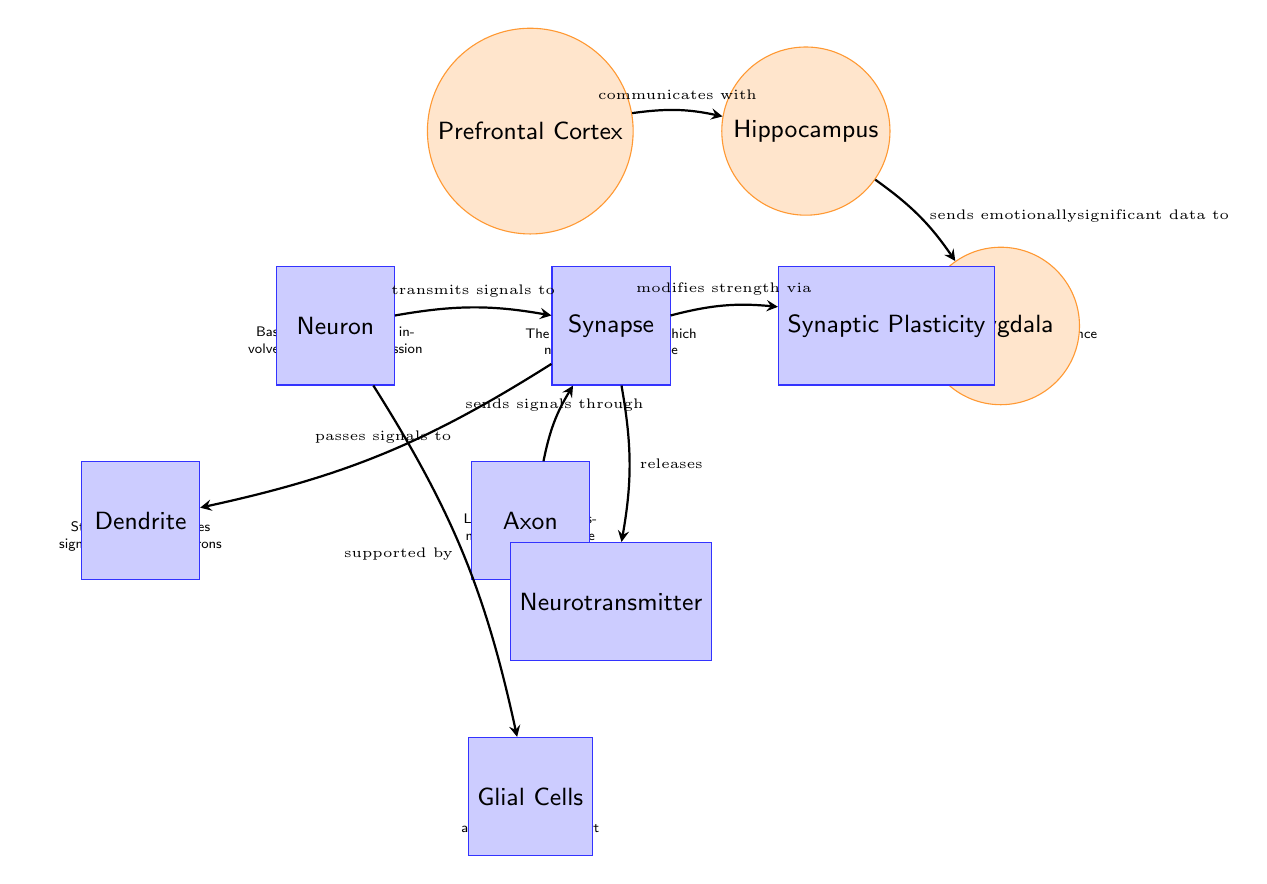What are the three main brain regions involved in memory retention shown in the diagram? The diagram features three main regions: the Prefrontal Cortex, the Hippocampus, and the Amygdala, all of which play crucial roles in memory retention.
Answer: Prefrontal Cortex, Hippocampus, Amygdala Which region communicates with the Hippocampus? According to the diagram, the Prefrontal Cortex is the node that communicates with the Hippocampus, as indicated by the arrow pointing from PFC to HC.
Answer: Prefrontal Cortex What is the function of the Hippocampus as depicted in the diagram? The diagram notes that the Hippocampus plays a key role in transferring short-term history memories to long-term storage, making it essential for memory formation.
Answer: Transferring short-term history to long-term storage How many processing units (neurons) are represented in the diagram? The diagram includes one neuron labeled as "Neuron" and one each for Dendrite and Axon, totaling three processing units.
Answer: 1 What role does the Amygdala play with respect to the Hippocampus according to the arrows in the diagram? The diagram indicates that the Hippocampus sends emotionally significant data to the Amygdala, showing its importance in emotional context for memory.
Answer: Sends emotionally significant data How does Synaptic Plasticity impact memories based on the diagram's information? The diagram illustrates that Synaptic Plasticity modifies the strength of synapses, which is crucial for the strengthening or weakening of memories over time.
Answer: Modifies strength of synapses What type of cells support neurons according to the diagram? The diagram identifies the Glial Cells as the type of cells that provide support to neurons, highlighted in the description near them.
Answer: Glial Cells Which neurotransmitter is released as mentioned in the diagram? The diagram describes Neurotransmitter as being released from Synapse, implying its role in signal transmission between neurons.
Answer: Neurotransmitter 